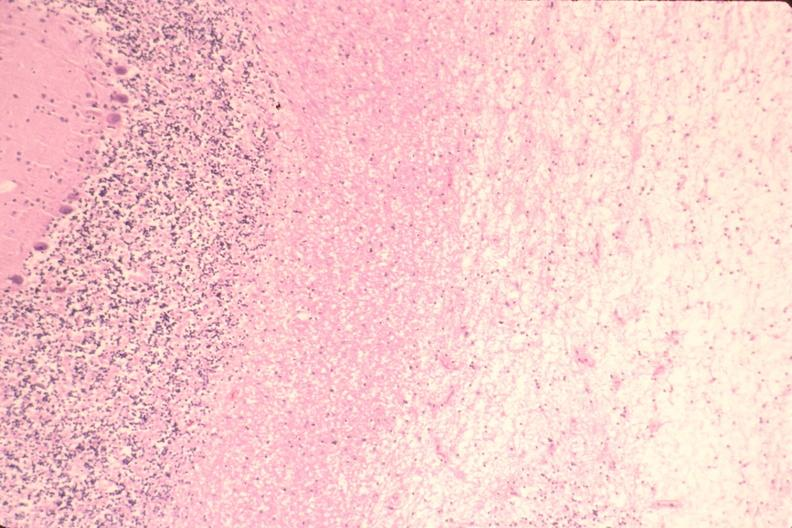where is this?
Answer the question using a single word or phrase. Nervous 